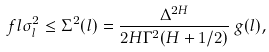Convert formula to latex. <formula><loc_0><loc_0><loc_500><loc_500>\ f l \sigma ^ { 2 } _ { l } \leq \Sigma ^ { 2 } ( l ) = \frac { \Delta ^ { 2 H } } { 2 H \Gamma ^ { 2 } ( H + 1 / 2 ) } \, g ( l ) ,</formula> 